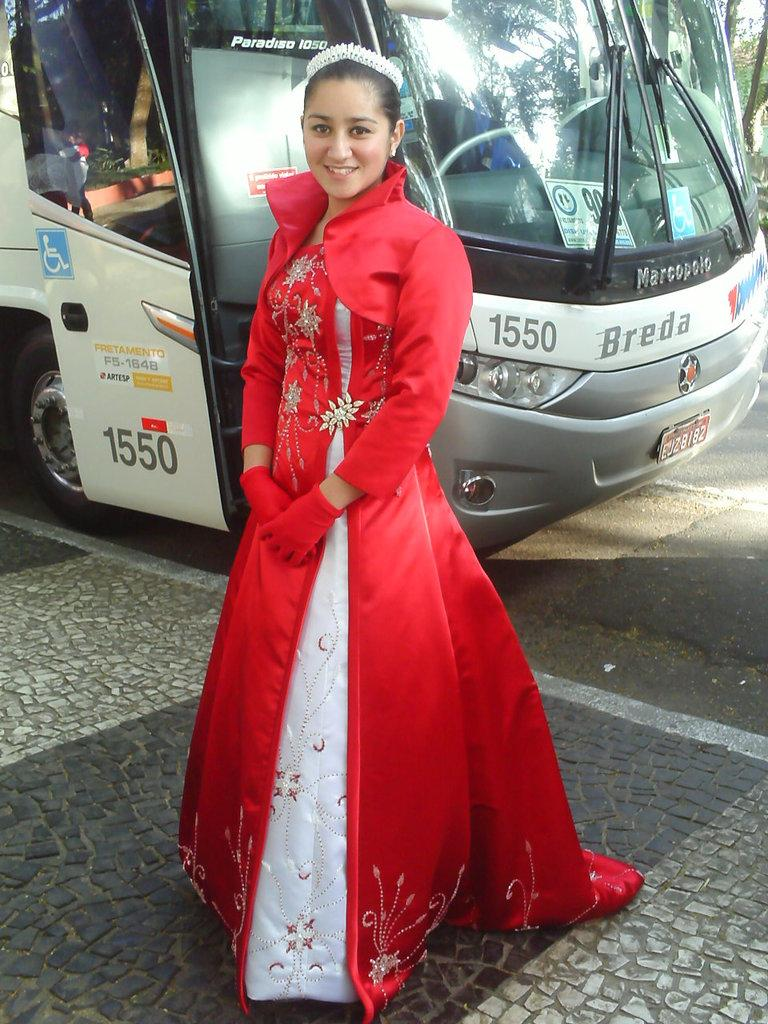Who is the main subject in the image? There is a girl in the image. What is the girl doing in the image? The girl is standing. What is the girl wearing in the image? The girl is wearing a red dress. What can be seen in the background of the image? There is a bus in the background of the image. What songs is the girl singing in the image? There is no indication in the image that the girl is singing any songs. 